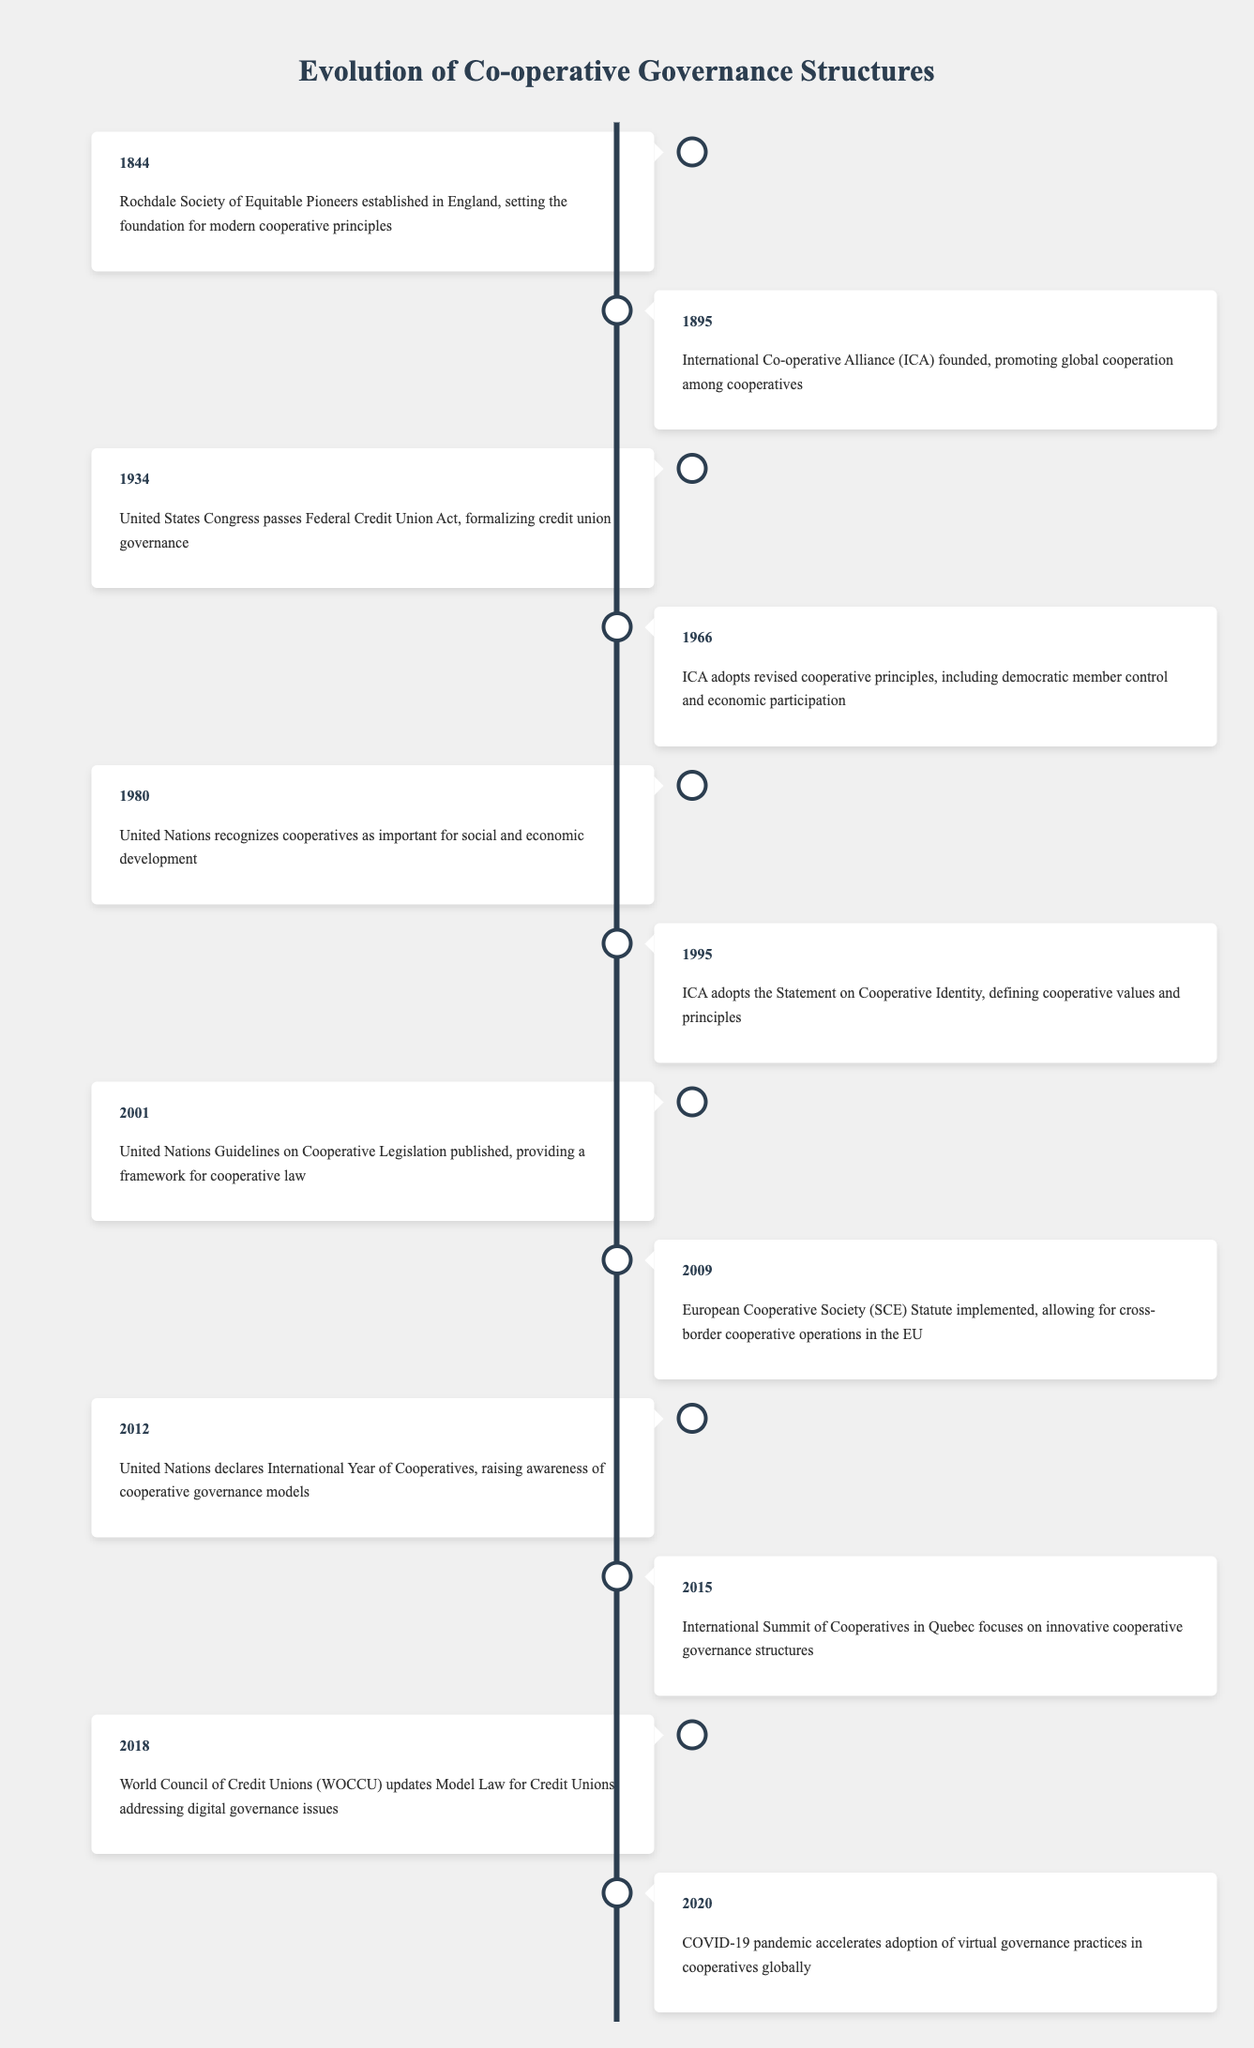What year was the Rochdale Society of Equitable Pioneers established? The table indicates that the Rochdale Society of Equitable Pioneers was established in the year 1844.
Answer: 1844 What event took place in 1966 related to cooperative principles? The table shows that in 1966, the International Co-operative Alliance adopted revised cooperative principles, which included democratic member control and economic participation.
Answer: ICA adopted revised cooperative principles How many years passed between the establishment of the Rochdale Society and the founding of the International Co-operative Alliance? The Rochdale Society was established in 1844 and the ICA was founded in 1895. The difference in years is 1895 - 1844 = 51 years.
Answer: 51 years Was the United Nations recognition of cooperatives as important for social and economic development before the year 2000? According to the table, the United Nations recognized cooperatives in the year 1980, which is before the year 2000.
Answer: Yes What significant governance framework was published in 2001? The table states that in 2001, the United Nations Guidelines on Cooperative Legislation were published, providing a framework for cooperative law.
Answer: UN Guidelines on Cooperative Legislation How many events mentioned in the table occurred before 2000? The events before 2000 include those in the years 1844, 1895, 1934, 1966, 1980, 1995, and 2001, totaling 7 events, but from 2001 onwards, there are no more ahead of 2000. So there are 8 events before the year 2000.
Answer: 8 events When was the International Year of Cooperatives declared by the United Nations? The table specifies that the United Nations declared the International Year of Cooperatives in 2012.
Answer: 2012 Did the COVID-19 pandemic accelerate the adoption of virtual governance practices in cooperatives? Yes, the table indicates that in 2020, the COVID-19 pandemic accelerated the adoption of virtual governance practices globally in cooperatives.
Answer: Yes What is the earliest recorded event in the timeline? The earliest recorded event in the table is from the year 1844, when the Rochdale Society of Equitable Pioneers was established.
Answer: 1844 